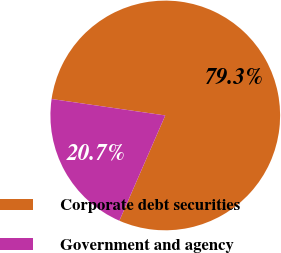<chart> <loc_0><loc_0><loc_500><loc_500><pie_chart><fcel>Corporate debt securities<fcel>Government and agency<nl><fcel>79.26%<fcel>20.74%<nl></chart> 